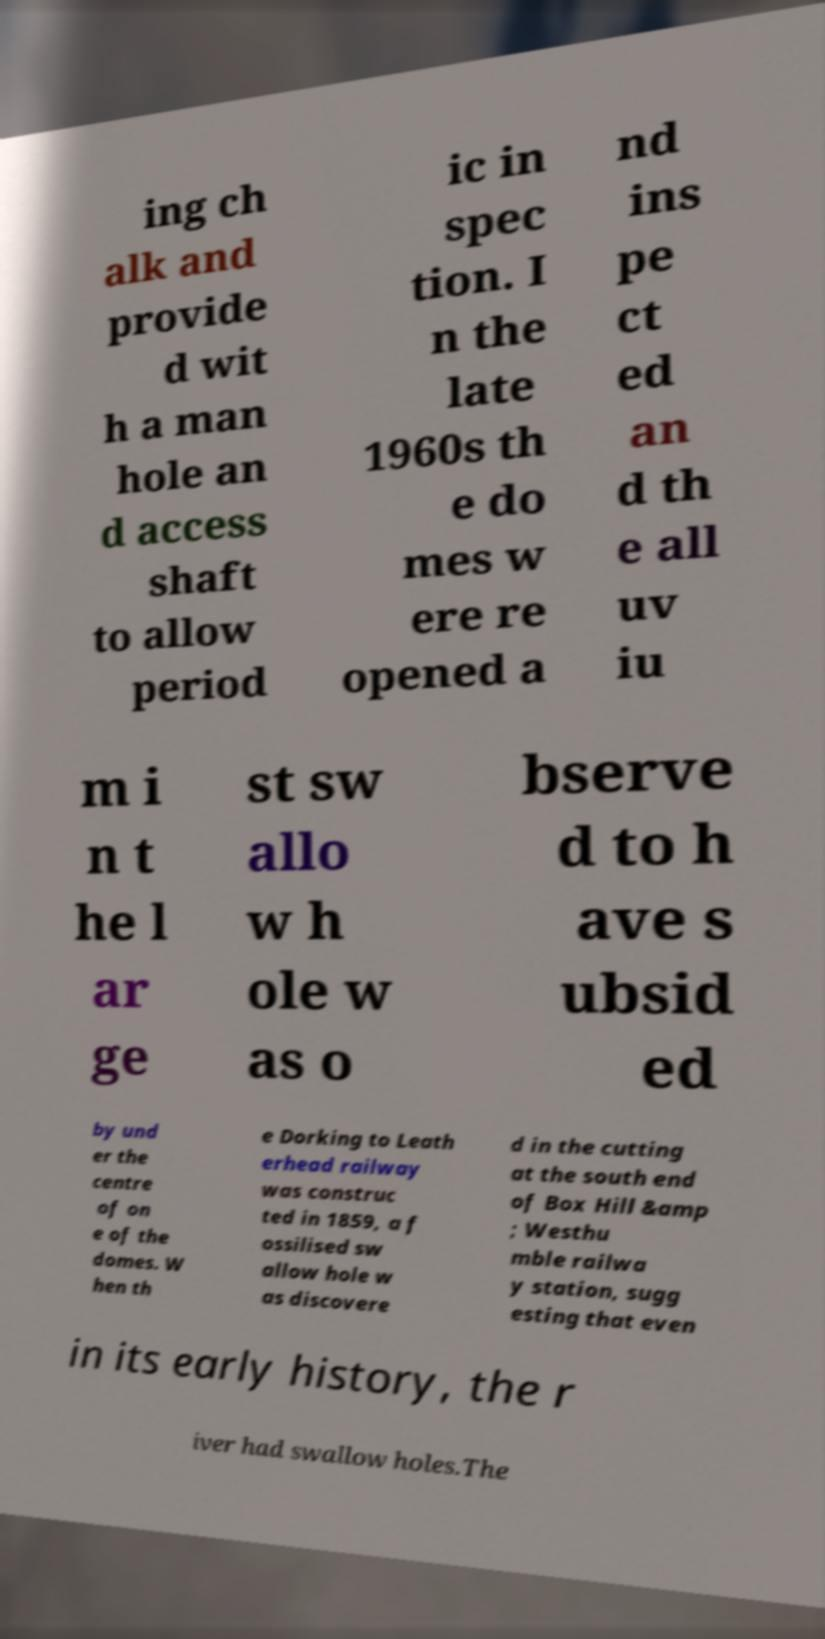Can you accurately transcribe the text from the provided image for me? ing ch alk and provide d wit h a man hole an d access shaft to allow period ic in spec tion. I n the late 1960s th e do mes w ere re opened a nd ins pe ct ed an d th e all uv iu m i n t he l ar ge st sw allo w h ole w as o bserve d to h ave s ubsid ed by und er the centre of on e of the domes. W hen th e Dorking to Leath erhead railway was construc ted in 1859, a f ossilised sw allow hole w as discovere d in the cutting at the south end of Box Hill &amp ; Westhu mble railwa y station, sugg esting that even in its early history, the r iver had swallow holes.The 